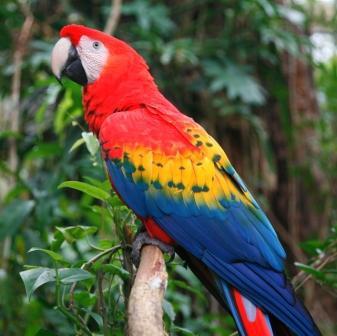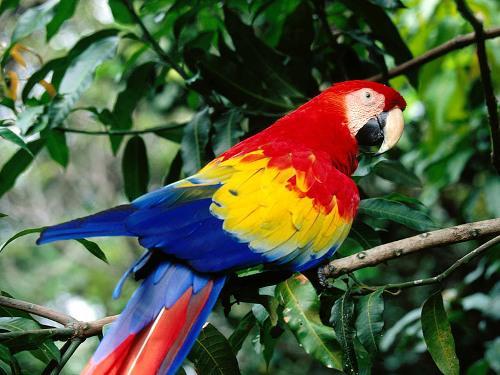The first image is the image on the left, the second image is the image on the right. Considering the images on both sides, is "Two birds are perched together in one of the images." valid? Answer yes or no. No. 